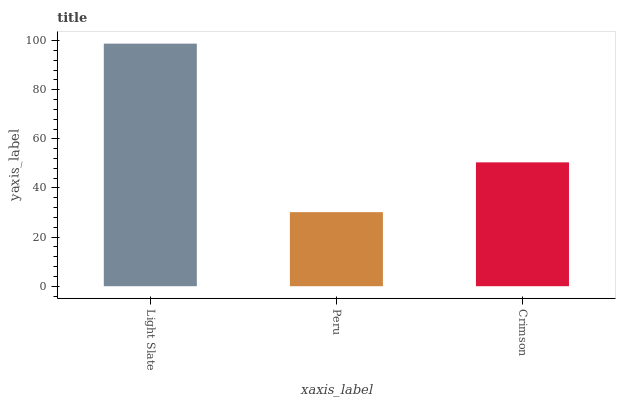Is Peru the minimum?
Answer yes or no. Yes. Is Light Slate the maximum?
Answer yes or no. Yes. Is Crimson the minimum?
Answer yes or no. No. Is Crimson the maximum?
Answer yes or no. No. Is Crimson greater than Peru?
Answer yes or no. Yes. Is Peru less than Crimson?
Answer yes or no. Yes. Is Peru greater than Crimson?
Answer yes or no. No. Is Crimson less than Peru?
Answer yes or no. No. Is Crimson the high median?
Answer yes or no. Yes. Is Crimson the low median?
Answer yes or no. Yes. Is Peru the high median?
Answer yes or no. No. Is Light Slate the low median?
Answer yes or no. No. 